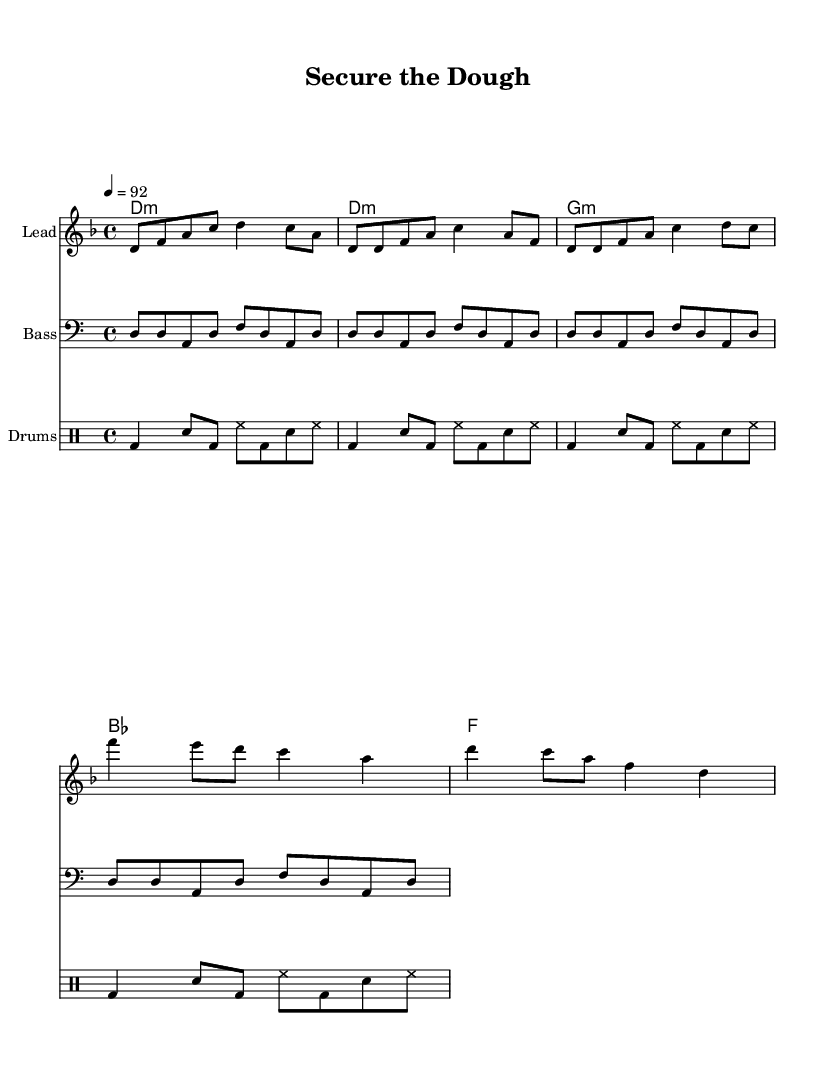What is the key signature of this music? The key signature indicated in the global settings is D minor, which has one flat. It can be identified by the "d" in the key signature notation.
Answer: D minor What is the time signature of this music? The time signature specified in the global settings is 4/4, which indicates that there are four beats in each measure and a quarter note receives one beat.
Answer: 4/4 What is the tempo marking in this music? The tempo is set to "4 = 92", which means there are 92 beats per minute, and each quarter note receives one beat.
Answer: 92 How many measures are in the verse section? The verse section consists of two lines, with a total of eight measures combined as seen in the melody section. Each line has four measures. Therefore, the verse has eight measures overall.
Answer: 8 What musical form is used in this track? The track follows a typical structure of verse-chorus, starting with a verse followed by a chorus, which repeats this structure. The repetition of the verse and chorus suggests a clear form.
Answer: Verse-Chorus How many different instruments are designated in the score? The score specifies four separate staves: one for lead, one for bass, one for drums, and one for chord names, indicating four different instrumental parts overall.
Answer: 4 What is the central theme of the lyrics? The lyrics focus on themes of cybersecurity and protection of digital assets, indicating the importance of securing information in the digital realm.
Answer: Cybersecurity 